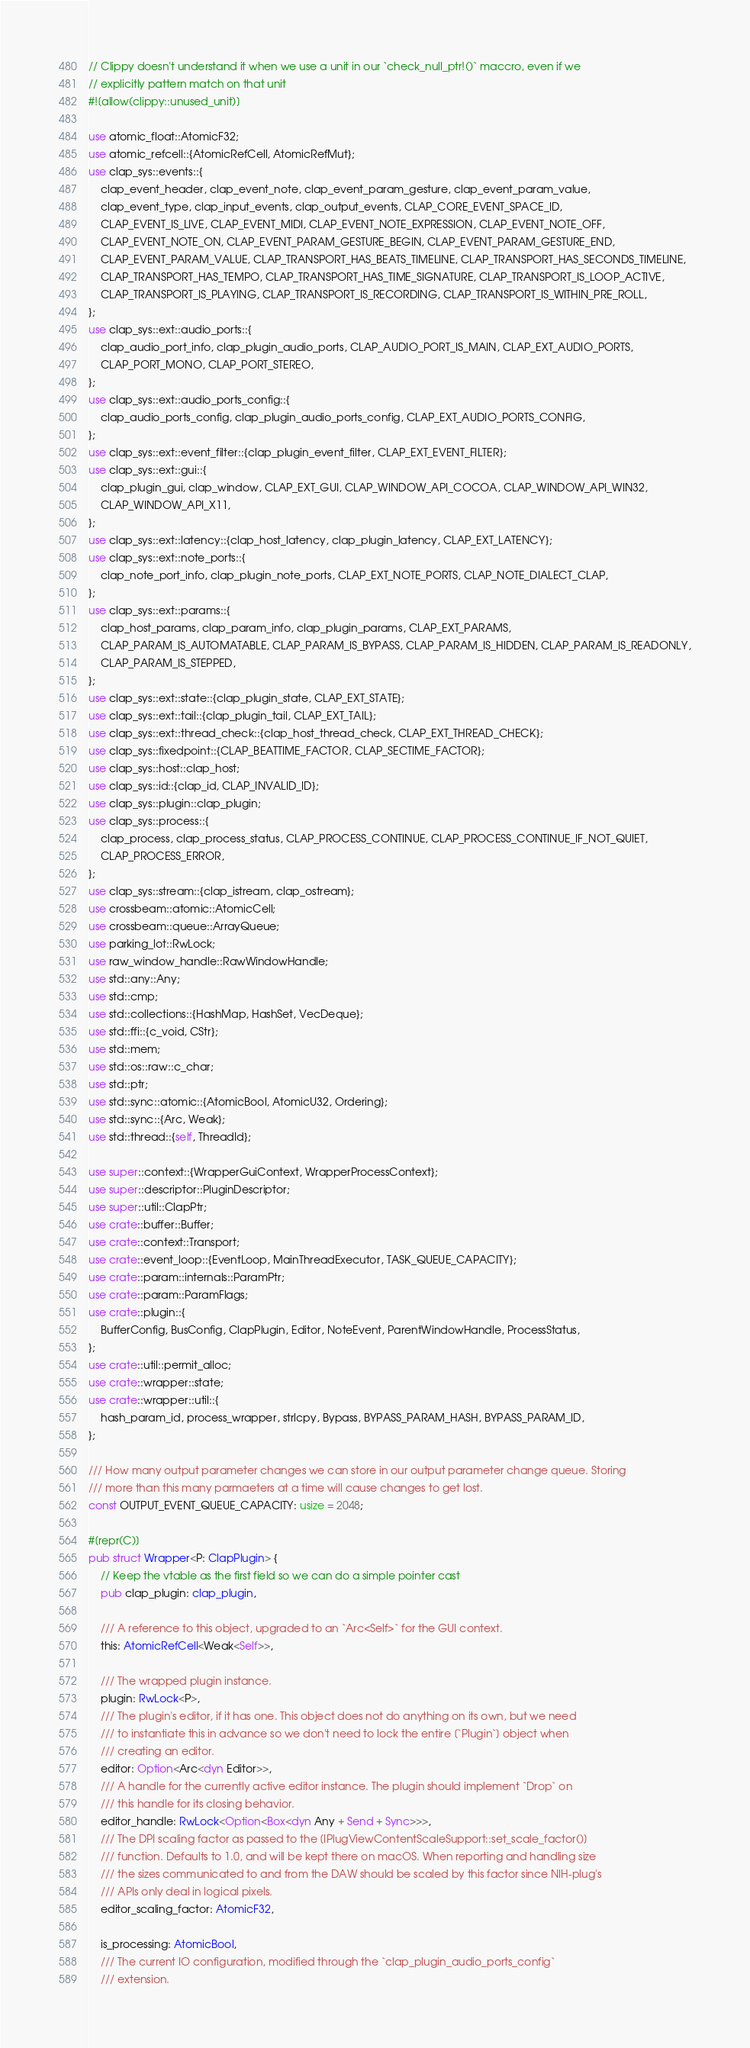Convert code to text. <code><loc_0><loc_0><loc_500><loc_500><_Rust_>// Clippy doesn't understand it when we use a unit in our `check_null_ptr!()` maccro, even if we
// explicitly pattern match on that unit
#![allow(clippy::unused_unit)]

use atomic_float::AtomicF32;
use atomic_refcell::{AtomicRefCell, AtomicRefMut};
use clap_sys::events::{
    clap_event_header, clap_event_note, clap_event_param_gesture, clap_event_param_value,
    clap_event_type, clap_input_events, clap_output_events, CLAP_CORE_EVENT_SPACE_ID,
    CLAP_EVENT_IS_LIVE, CLAP_EVENT_MIDI, CLAP_EVENT_NOTE_EXPRESSION, CLAP_EVENT_NOTE_OFF,
    CLAP_EVENT_NOTE_ON, CLAP_EVENT_PARAM_GESTURE_BEGIN, CLAP_EVENT_PARAM_GESTURE_END,
    CLAP_EVENT_PARAM_VALUE, CLAP_TRANSPORT_HAS_BEATS_TIMELINE, CLAP_TRANSPORT_HAS_SECONDS_TIMELINE,
    CLAP_TRANSPORT_HAS_TEMPO, CLAP_TRANSPORT_HAS_TIME_SIGNATURE, CLAP_TRANSPORT_IS_LOOP_ACTIVE,
    CLAP_TRANSPORT_IS_PLAYING, CLAP_TRANSPORT_IS_RECORDING, CLAP_TRANSPORT_IS_WITHIN_PRE_ROLL,
};
use clap_sys::ext::audio_ports::{
    clap_audio_port_info, clap_plugin_audio_ports, CLAP_AUDIO_PORT_IS_MAIN, CLAP_EXT_AUDIO_PORTS,
    CLAP_PORT_MONO, CLAP_PORT_STEREO,
};
use clap_sys::ext::audio_ports_config::{
    clap_audio_ports_config, clap_plugin_audio_ports_config, CLAP_EXT_AUDIO_PORTS_CONFIG,
};
use clap_sys::ext::event_filter::{clap_plugin_event_filter, CLAP_EXT_EVENT_FILTER};
use clap_sys::ext::gui::{
    clap_plugin_gui, clap_window, CLAP_EXT_GUI, CLAP_WINDOW_API_COCOA, CLAP_WINDOW_API_WIN32,
    CLAP_WINDOW_API_X11,
};
use clap_sys::ext::latency::{clap_host_latency, clap_plugin_latency, CLAP_EXT_LATENCY};
use clap_sys::ext::note_ports::{
    clap_note_port_info, clap_plugin_note_ports, CLAP_EXT_NOTE_PORTS, CLAP_NOTE_DIALECT_CLAP,
};
use clap_sys::ext::params::{
    clap_host_params, clap_param_info, clap_plugin_params, CLAP_EXT_PARAMS,
    CLAP_PARAM_IS_AUTOMATABLE, CLAP_PARAM_IS_BYPASS, CLAP_PARAM_IS_HIDDEN, CLAP_PARAM_IS_READONLY,
    CLAP_PARAM_IS_STEPPED,
};
use clap_sys::ext::state::{clap_plugin_state, CLAP_EXT_STATE};
use clap_sys::ext::tail::{clap_plugin_tail, CLAP_EXT_TAIL};
use clap_sys::ext::thread_check::{clap_host_thread_check, CLAP_EXT_THREAD_CHECK};
use clap_sys::fixedpoint::{CLAP_BEATTIME_FACTOR, CLAP_SECTIME_FACTOR};
use clap_sys::host::clap_host;
use clap_sys::id::{clap_id, CLAP_INVALID_ID};
use clap_sys::plugin::clap_plugin;
use clap_sys::process::{
    clap_process, clap_process_status, CLAP_PROCESS_CONTINUE, CLAP_PROCESS_CONTINUE_IF_NOT_QUIET,
    CLAP_PROCESS_ERROR,
};
use clap_sys::stream::{clap_istream, clap_ostream};
use crossbeam::atomic::AtomicCell;
use crossbeam::queue::ArrayQueue;
use parking_lot::RwLock;
use raw_window_handle::RawWindowHandle;
use std::any::Any;
use std::cmp;
use std::collections::{HashMap, HashSet, VecDeque};
use std::ffi::{c_void, CStr};
use std::mem;
use std::os::raw::c_char;
use std::ptr;
use std::sync::atomic::{AtomicBool, AtomicU32, Ordering};
use std::sync::{Arc, Weak};
use std::thread::{self, ThreadId};

use super::context::{WrapperGuiContext, WrapperProcessContext};
use super::descriptor::PluginDescriptor;
use super::util::ClapPtr;
use crate::buffer::Buffer;
use crate::context::Transport;
use crate::event_loop::{EventLoop, MainThreadExecutor, TASK_QUEUE_CAPACITY};
use crate::param::internals::ParamPtr;
use crate::param::ParamFlags;
use crate::plugin::{
    BufferConfig, BusConfig, ClapPlugin, Editor, NoteEvent, ParentWindowHandle, ProcessStatus,
};
use crate::util::permit_alloc;
use crate::wrapper::state;
use crate::wrapper::util::{
    hash_param_id, process_wrapper, strlcpy, Bypass, BYPASS_PARAM_HASH, BYPASS_PARAM_ID,
};

/// How many output parameter changes we can store in our output parameter change queue. Storing
/// more than this many parmaeters at a time will cause changes to get lost.
const OUTPUT_EVENT_QUEUE_CAPACITY: usize = 2048;

#[repr(C)]
pub struct Wrapper<P: ClapPlugin> {
    // Keep the vtable as the first field so we can do a simple pointer cast
    pub clap_plugin: clap_plugin,

    /// A reference to this object, upgraded to an `Arc<Self>` for the GUI context.
    this: AtomicRefCell<Weak<Self>>,

    /// The wrapped plugin instance.
    plugin: RwLock<P>,
    /// The plugin's editor, if it has one. This object does not do anything on its own, but we need
    /// to instantiate this in advance so we don't need to lock the entire [`Plugin`] object when
    /// creating an editor.
    editor: Option<Arc<dyn Editor>>,
    /// A handle for the currently active editor instance. The plugin should implement `Drop` on
    /// this handle for its closing behavior.
    editor_handle: RwLock<Option<Box<dyn Any + Send + Sync>>>,
    /// The DPI scaling factor as passed to the [IPlugViewContentScaleSupport::set_scale_factor()]
    /// function. Defaults to 1.0, and will be kept there on macOS. When reporting and handling size
    /// the sizes communicated to and from the DAW should be scaled by this factor since NIH-plug's
    /// APIs only deal in logical pixels.
    editor_scaling_factor: AtomicF32,

    is_processing: AtomicBool,
    /// The current IO configuration, modified through the `clap_plugin_audio_ports_config`
    /// extension.</code> 